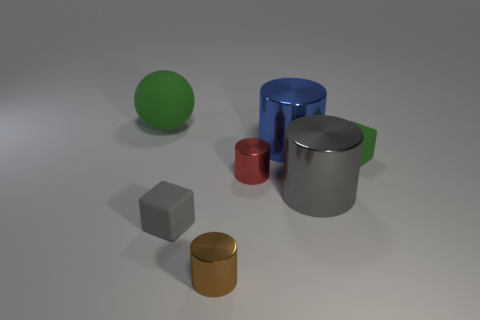Subtract all big blue metallic cylinders. How many cylinders are left? 3 Subtract all green cubes. How many cubes are left? 1 Add 1 gray blocks. How many objects exist? 8 Subtract 0 purple spheres. How many objects are left? 7 Subtract all cubes. How many objects are left? 5 Subtract 1 spheres. How many spheres are left? 0 Subtract all red balls. Subtract all brown cylinders. How many balls are left? 1 Subtract all gray cylinders. How many green blocks are left? 1 Subtract all big purple metal spheres. Subtract all blue shiny objects. How many objects are left? 6 Add 4 matte blocks. How many matte blocks are left? 6 